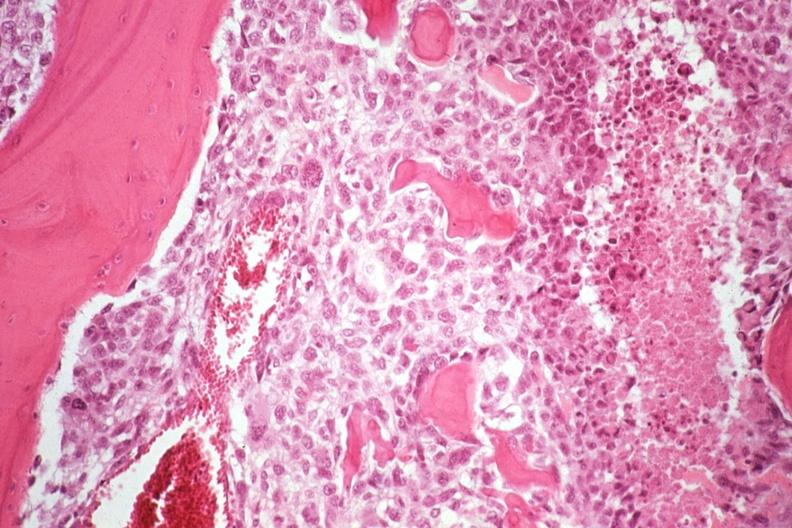does this image show neoplastic osteoblasts and tumor osteoid?
Answer the question using a single word or phrase. Yes 